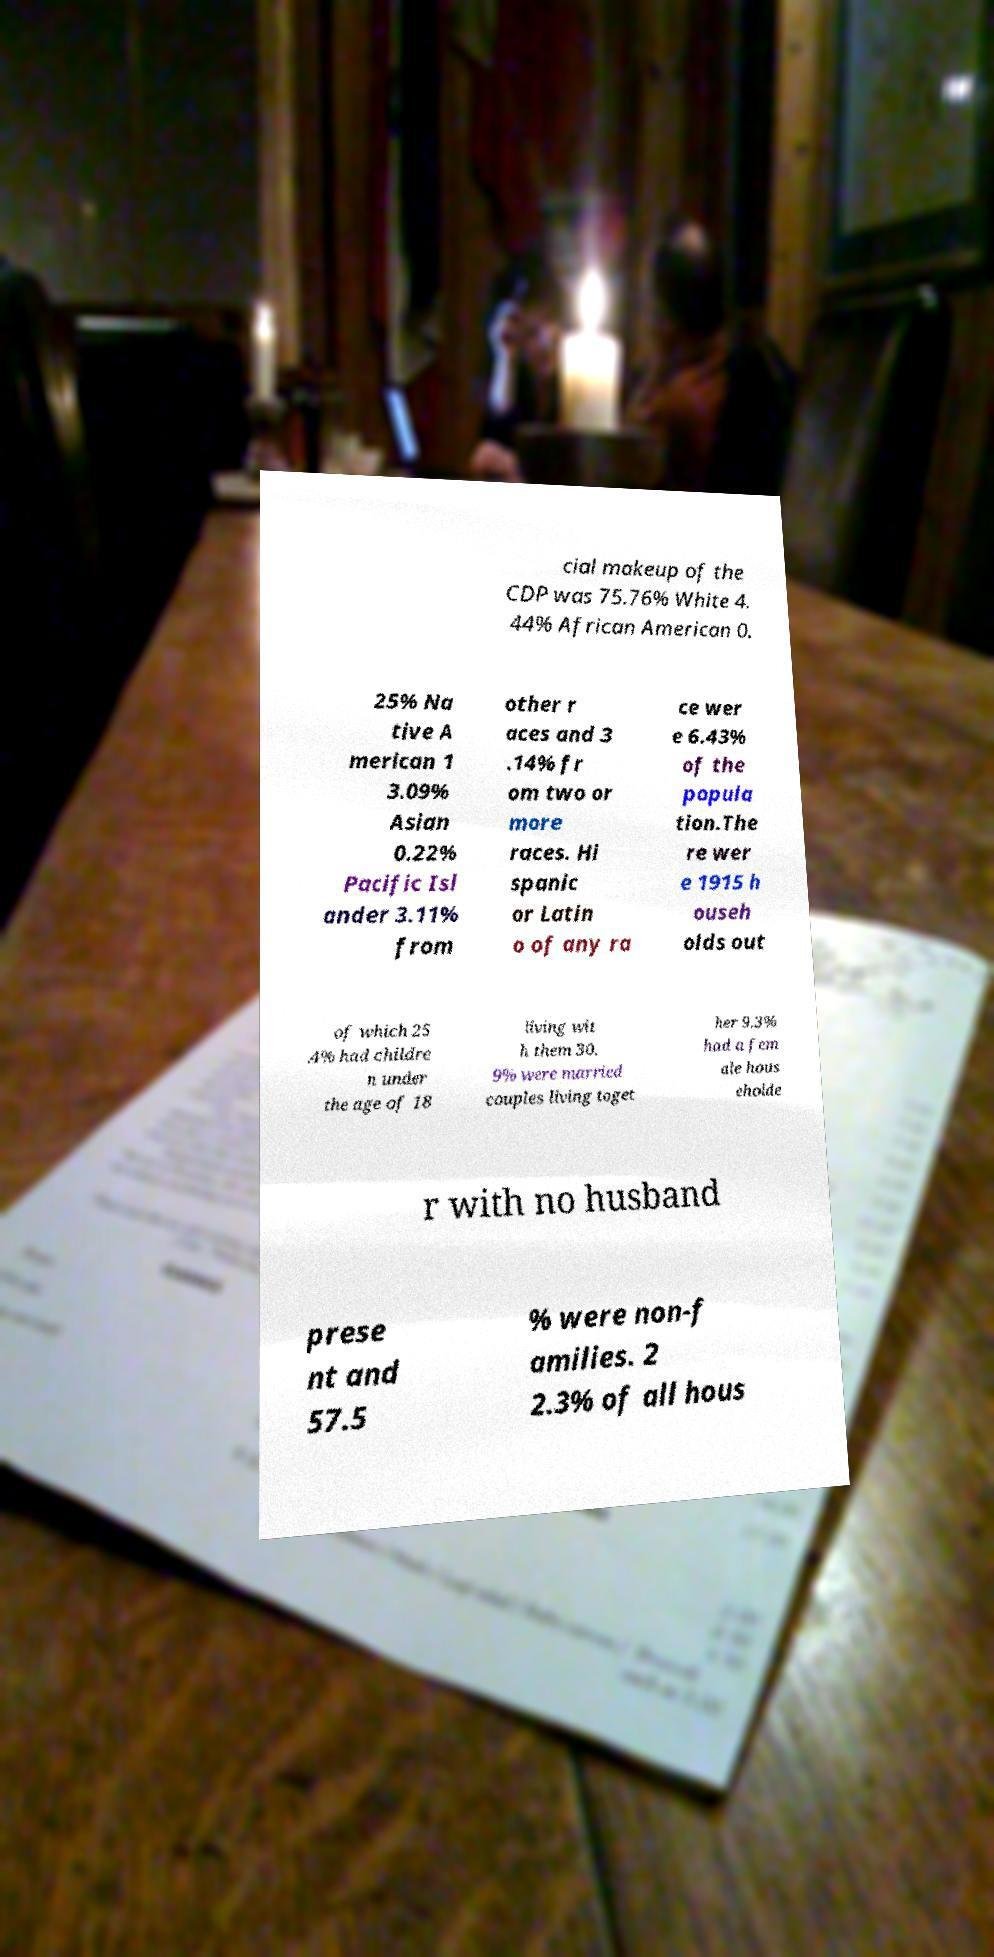I need the written content from this picture converted into text. Can you do that? cial makeup of the CDP was 75.76% White 4. 44% African American 0. 25% Na tive A merican 1 3.09% Asian 0.22% Pacific Isl ander 3.11% from other r aces and 3 .14% fr om two or more races. Hi spanic or Latin o of any ra ce wer e 6.43% of the popula tion.The re wer e 1915 h ouseh olds out of which 25 .4% had childre n under the age of 18 living wit h them 30. 9% were married couples living toget her 9.3% had a fem ale hous eholde r with no husband prese nt and 57.5 % were non-f amilies. 2 2.3% of all hous 